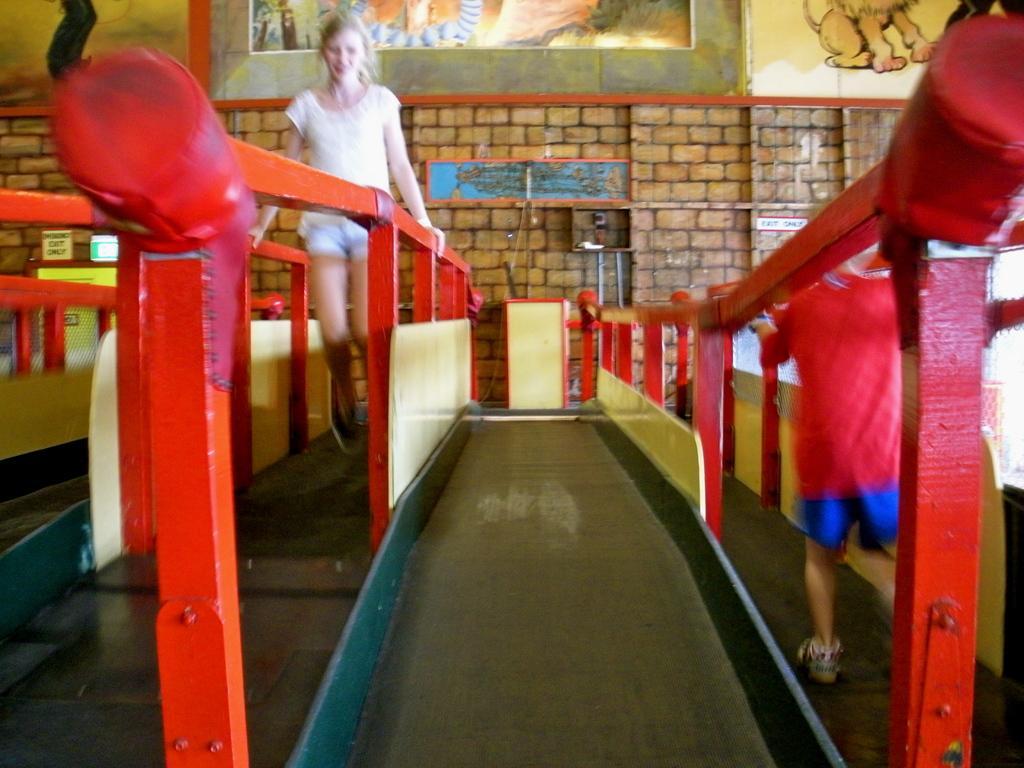Please provide a concise description of this image. In this picture, we see the girl in white dress is in between the railing. These railings are in red color. Beside her, we see a slider. She might be playing. On the right side, the boy in red T-shirt is standing. Behind them, we see a wall which is made up of bricks. We see photo frames are placed on the wall. This picture might be clicked in the playroom. 